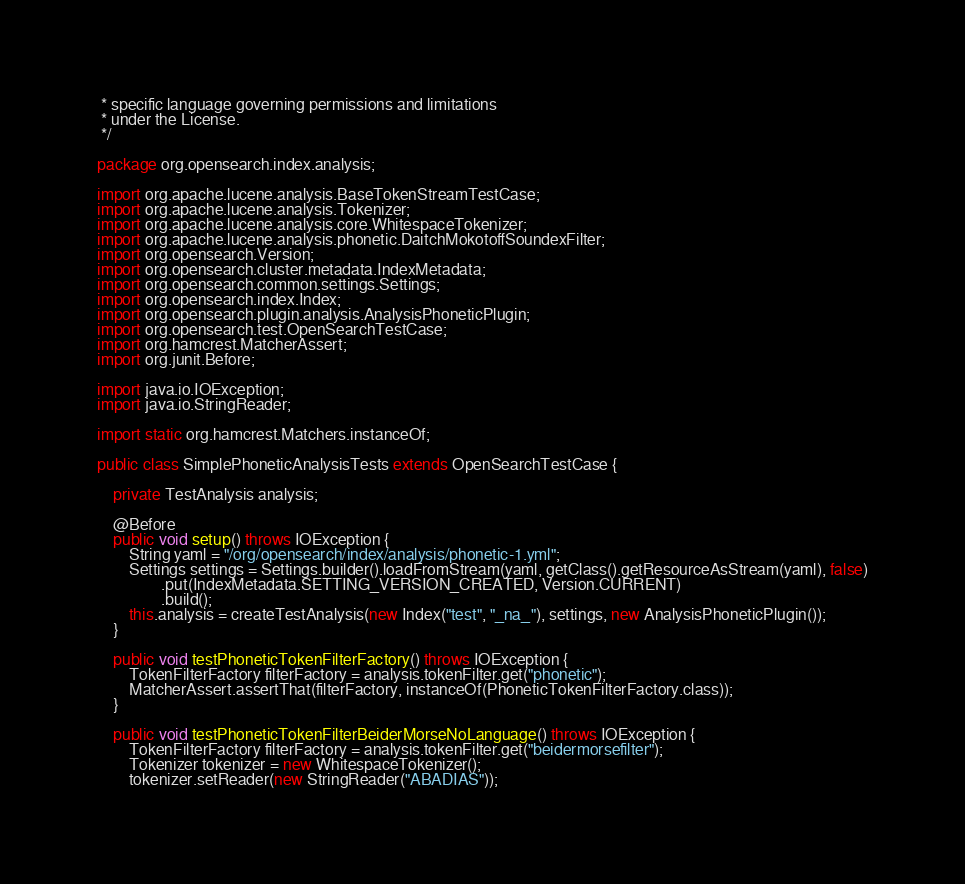Convert code to text. <code><loc_0><loc_0><loc_500><loc_500><_Java_> * specific language governing permissions and limitations
 * under the License.
 */

package org.opensearch.index.analysis;

import org.apache.lucene.analysis.BaseTokenStreamTestCase;
import org.apache.lucene.analysis.Tokenizer;
import org.apache.lucene.analysis.core.WhitespaceTokenizer;
import org.apache.lucene.analysis.phonetic.DaitchMokotoffSoundexFilter;
import org.opensearch.Version;
import org.opensearch.cluster.metadata.IndexMetadata;
import org.opensearch.common.settings.Settings;
import org.opensearch.index.Index;
import org.opensearch.plugin.analysis.AnalysisPhoneticPlugin;
import org.opensearch.test.OpenSearchTestCase;
import org.hamcrest.MatcherAssert;
import org.junit.Before;

import java.io.IOException;
import java.io.StringReader;

import static org.hamcrest.Matchers.instanceOf;

public class SimplePhoneticAnalysisTests extends OpenSearchTestCase {

    private TestAnalysis analysis;

    @Before
    public void setup() throws IOException {
        String yaml = "/org/opensearch/index/analysis/phonetic-1.yml";
        Settings settings = Settings.builder().loadFromStream(yaml, getClass().getResourceAsStream(yaml), false)
                .put(IndexMetadata.SETTING_VERSION_CREATED, Version.CURRENT)
                .build();
        this.analysis = createTestAnalysis(new Index("test", "_na_"), settings, new AnalysisPhoneticPlugin());
    }

    public void testPhoneticTokenFilterFactory() throws IOException {
        TokenFilterFactory filterFactory = analysis.tokenFilter.get("phonetic");
        MatcherAssert.assertThat(filterFactory, instanceOf(PhoneticTokenFilterFactory.class));
    }

    public void testPhoneticTokenFilterBeiderMorseNoLanguage() throws IOException {
        TokenFilterFactory filterFactory = analysis.tokenFilter.get("beidermorsefilter");
        Tokenizer tokenizer = new WhitespaceTokenizer();
        tokenizer.setReader(new StringReader("ABADIAS"));</code> 